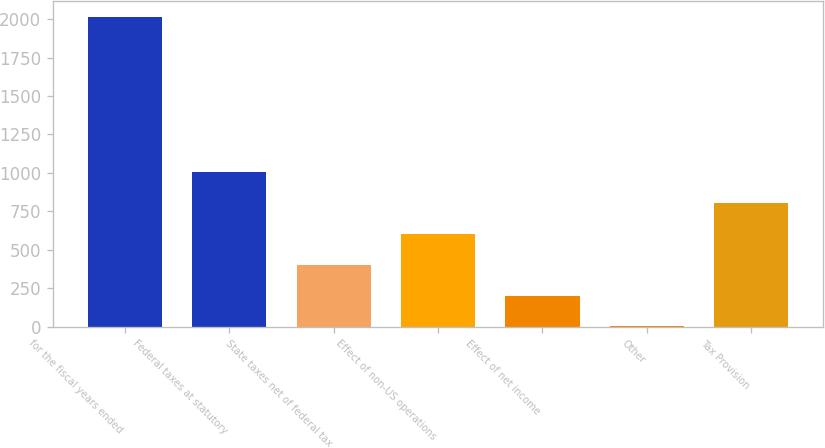<chart> <loc_0><loc_0><loc_500><loc_500><bar_chart><fcel>for the fiscal years ended<fcel>Federal taxes at statutory<fcel>State taxes net of federal tax<fcel>Effect of non-US operations<fcel>Effect of net income<fcel>Other<fcel>Tax Provision<nl><fcel>2015<fcel>1007.75<fcel>403.4<fcel>604.85<fcel>201.95<fcel>0.5<fcel>806.3<nl></chart> 